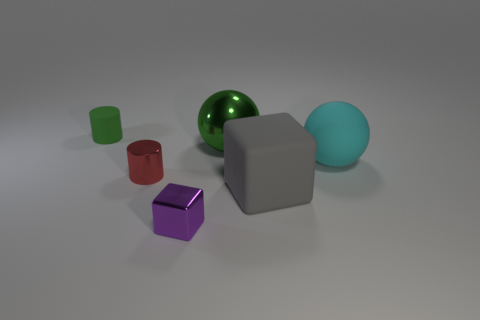Is the number of large green spheres that are behind the small green rubber cylinder less than the number of large yellow cylinders?
Make the answer very short. No. There is a large object that is made of the same material as the large block; what shape is it?
Make the answer very short. Sphere. Are the gray cube and the tiny cube made of the same material?
Your answer should be very brief. No. Is the number of green objects that are in front of the big gray object less than the number of tiny rubber cylinders that are behind the matte sphere?
Make the answer very short. Yes. The ball that is the same color as the rubber cylinder is what size?
Your response must be concise. Large. What number of large matte cubes are to the right of the small metal thing that is left of the small purple block that is to the left of the large metallic sphere?
Keep it short and to the point. 1. Do the tiny matte cylinder and the shiny ball have the same color?
Your answer should be very brief. Yes. Are there any other objects that have the same color as the big metal object?
Offer a very short reply. Yes. There is a metallic thing that is the same size as the gray rubber thing; what color is it?
Offer a terse response. Green. Are there any big yellow matte things of the same shape as the green rubber object?
Provide a succinct answer. No. 